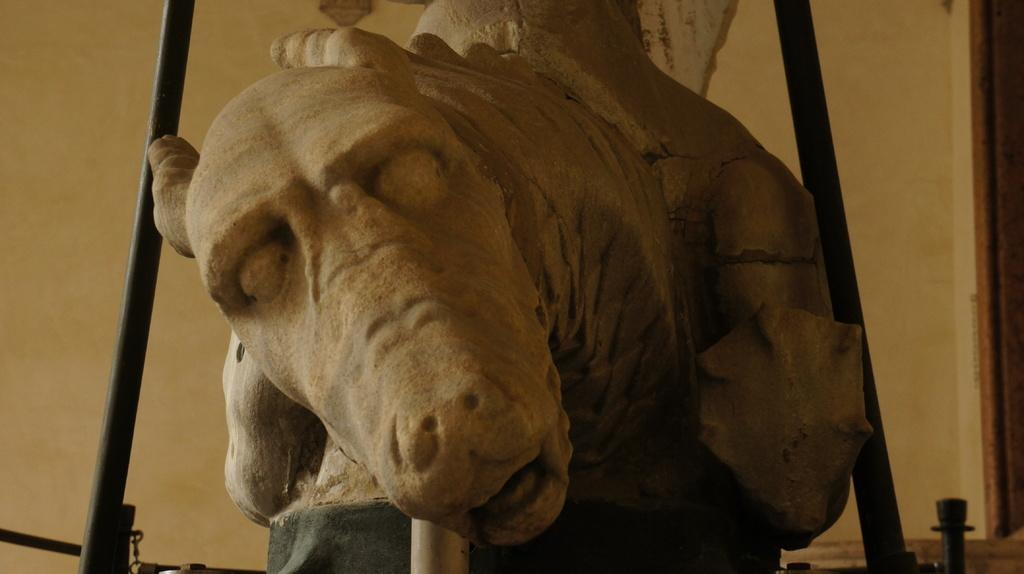What is the main subject in the image? There is a statue in the image. What is located behind the statue? There is a wall behind the statue in the image. How does the statue make people feel in the image? The image does not convey any specific feelings or emotions that people might experience when looking at the statue. 